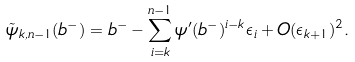Convert formula to latex. <formula><loc_0><loc_0><loc_500><loc_500>\tilde { \psi } _ { k , n - 1 } ( b ^ { - } ) = b ^ { - } - \sum _ { i = k } ^ { n - 1 } \psi ^ { \prime } ( b ^ { - } ) ^ { i - k } \epsilon _ { i } + O ( \epsilon _ { k + 1 } ) ^ { 2 } .</formula> 